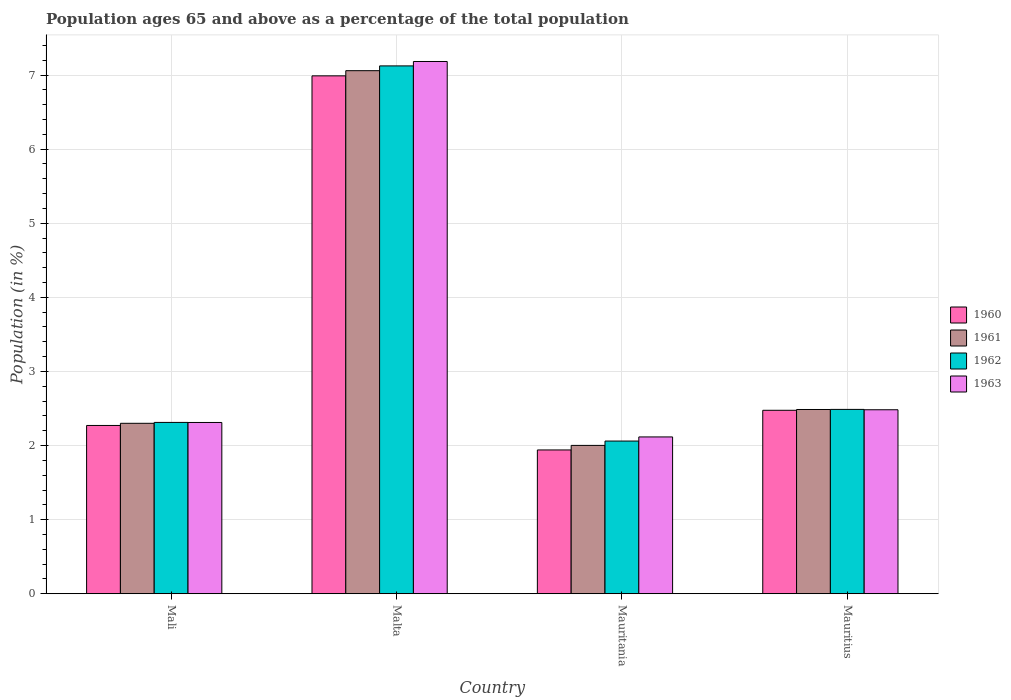How many groups of bars are there?
Provide a succinct answer. 4. How many bars are there on the 1st tick from the right?
Provide a short and direct response. 4. What is the label of the 4th group of bars from the left?
Keep it short and to the point. Mauritius. In how many cases, is the number of bars for a given country not equal to the number of legend labels?
Offer a very short reply. 0. What is the percentage of the population ages 65 and above in 1962 in Mauritania?
Keep it short and to the point. 2.06. Across all countries, what is the maximum percentage of the population ages 65 and above in 1963?
Ensure brevity in your answer.  7.18. Across all countries, what is the minimum percentage of the population ages 65 and above in 1961?
Your answer should be very brief. 2. In which country was the percentage of the population ages 65 and above in 1960 maximum?
Keep it short and to the point. Malta. In which country was the percentage of the population ages 65 and above in 1962 minimum?
Keep it short and to the point. Mauritania. What is the total percentage of the population ages 65 and above in 1963 in the graph?
Your response must be concise. 14.09. What is the difference between the percentage of the population ages 65 and above in 1962 in Mauritania and that in Mauritius?
Offer a terse response. -0.43. What is the difference between the percentage of the population ages 65 and above in 1961 in Mauritius and the percentage of the population ages 65 and above in 1960 in Mali?
Keep it short and to the point. 0.22. What is the average percentage of the population ages 65 and above in 1962 per country?
Make the answer very short. 3.5. What is the difference between the percentage of the population ages 65 and above of/in 1961 and percentage of the population ages 65 and above of/in 1962 in Mauritania?
Offer a terse response. -0.06. In how many countries, is the percentage of the population ages 65 and above in 1960 greater than 6.6?
Your response must be concise. 1. What is the ratio of the percentage of the population ages 65 and above in 1960 in Malta to that in Mauritius?
Your response must be concise. 2.82. What is the difference between the highest and the second highest percentage of the population ages 65 and above in 1960?
Provide a short and direct response. 0.2. What is the difference between the highest and the lowest percentage of the population ages 65 and above in 1961?
Keep it short and to the point. 5.06. In how many countries, is the percentage of the population ages 65 and above in 1960 greater than the average percentage of the population ages 65 and above in 1960 taken over all countries?
Keep it short and to the point. 1. What does the 2nd bar from the left in Malta represents?
Provide a succinct answer. 1961. What does the 3rd bar from the right in Malta represents?
Your answer should be very brief. 1961. Is it the case that in every country, the sum of the percentage of the population ages 65 and above in 1962 and percentage of the population ages 65 and above in 1960 is greater than the percentage of the population ages 65 and above in 1961?
Your answer should be very brief. Yes. How many bars are there?
Keep it short and to the point. 16. How many countries are there in the graph?
Ensure brevity in your answer.  4. Are the values on the major ticks of Y-axis written in scientific E-notation?
Offer a terse response. No. Does the graph contain grids?
Provide a short and direct response. Yes. What is the title of the graph?
Give a very brief answer. Population ages 65 and above as a percentage of the total population. What is the label or title of the Y-axis?
Your answer should be compact. Population (in %). What is the Population (in %) in 1960 in Mali?
Keep it short and to the point. 2.27. What is the Population (in %) of 1961 in Mali?
Your answer should be very brief. 2.3. What is the Population (in %) of 1962 in Mali?
Keep it short and to the point. 2.31. What is the Population (in %) in 1963 in Mali?
Your response must be concise. 2.31. What is the Population (in %) of 1960 in Malta?
Your response must be concise. 6.99. What is the Population (in %) of 1961 in Malta?
Offer a very short reply. 7.06. What is the Population (in %) of 1962 in Malta?
Make the answer very short. 7.12. What is the Population (in %) of 1963 in Malta?
Your answer should be compact. 7.18. What is the Population (in %) in 1960 in Mauritania?
Offer a very short reply. 1.94. What is the Population (in %) of 1961 in Mauritania?
Provide a short and direct response. 2. What is the Population (in %) in 1962 in Mauritania?
Offer a very short reply. 2.06. What is the Population (in %) of 1963 in Mauritania?
Keep it short and to the point. 2.12. What is the Population (in %) in 1960 in Mauritius?
Provide a succinct answer. 2.48. What is the Population (in %) of 1961 in Mauritius?
Your response must be concise. 2.49. What is the Population (in %) of 1962 in Mauritius?
Offer a very short reply. 2.49. What is the Population (in %) in 1963 in Mauritius?
Make the answer very short. 2.48. Across all countries, what is the maximum Population (in %) in 1960?
Your answer should be very brief. 6.99. Across all countries, what is the maximum Population (in %) in 1961?
Your answer should be very brief. 7.06. Across all countries, what is the maximum Population (in %) in 1962?
Offer a very short reply. 7.12. Across all countries, what is the maximum Population (in %) in 1963?
Give a very brief answer. 7.18. Across all countries, what is the minimum Population (in %) of 1960?
Ensure brevity in your answer.  1.94. Across all countries, what is the minimum Population (in %) in 1961?
Your answer should be very brief. 2. Across all countries, what is the minimum Population (in %) in 1962?
Your answer should be compact. 2.06. Across all countries, what is the minimum Population (in %) of 1963?
Your answer should be very brief. 2.12. What is the total Population (in %) of 1960 in the graph?
Keep it short and to the point. 13.68. What is the total Population (in %) of 1961 in the graph?
Give a very brief answer. 13.85. What is the total Population (in %) of 1962 in the graph?
Make the answer very short. 13.98. What is the total Population (in %) of 1963 in the graph?
Make the answer very short. 14.09. What is the difference between the Population (in %) of 1960 in Mali and that in Malta?
Give a very brief answer. -4.72. What is the difference between the Population (in %) in 1961 in Mali and that in Malta?
Your answer should be very brief. -4.76. What is the difference between the Population (in %) of 1962 in Mali and that in Malta?
Make the answer very short. -4.81. What is the difference between the Population (in %) of 1963 in Mali and that in Malta?
Your response must be concise. -4.87. What is the difference between the Population (in %) of 1960 in Mali and that in Mauritania?
Give a very brief answer. 0.33. What is the difference between the Population (in %) in 1961 in Mali and that in Mauritania?
Give a very brief answer. 0.3. What is the difference between the Population (in %) of 1962 in Mali and that in Mauritania?
Provide a succinct answer. 0.25. What is the difference between the Population (in %) in 1963 in Mali and that in Mauritania?
Provide a succinct answer. 0.2. What is the difference between the Population (in %) in 1960 in Mali and that in Mauritius?
Your answer should be compact. -0.2. What is the difference between the Population (in %) in 1961 in Mali and that in Mauritius?
Give a very brief answer. -0.19. What is the difference between the Population (in %) in 1962 in Mali and that in Mauritius?
Give a very brief answer. -0.18. What is the difference between the Population (in %) of 1963 in Mali and that in Mauritius?
Ensure brevity in your answer.  -0.17. What is the difference between the Population (in %) in 1960 in Malta and that in Mauritania?
Keep it short and to the point. 5.05. What is the difference between the Population (in %) of 1961 in Malta and that in Mauritania?
Provide a succinct answer. 5.06. What is the difference between the Population (in %) of 1962 in Malta and that in Mauritania?
Provide a succinct answer. 5.06. What is the difference between the Population (in %) in 1963 in Malta and that in Mauritania?
Offer a terse response. 5.07. What is the difference between the Population (in %) in 1960 in Malta and that in Mauritius?
Your response must be concise. 4.51. What is the difference between the Population (in %) in 1961 in Malta and that in Mauritius?
Keep it short and to the point. 4.57. What is the difference between the Population (in %) of 1962 in Malta and that in Mauritius?
Offer a very short reply. 4.64. What is the difference between the Population (in %) in 1963 in Malta and that in Mauritius?
Offer a terse response. 4.7. What is the difference between the Population (in %) of 1960 in Mauritania and that in Mauritius?
Keep it short and to the point. -0.54. What is the difference between the Population (in %) in 1961 in Mauritania and that in Mauritius?
Keep it short and to the point. -0.48. What is the difference between the Population (in %) of 1962 in Mauritania and that in Mauritius?
Provide a short and direct response. -0.43. What is the difference between the Population (in %) of 1963 in Mauritania and that in Mauritius?
Provide a short and direct response. -0.37. What is the difference between the Population (in %) in 1960 in Mali and the Population (in %) in 1961 in Malta?
Give a very brief answer. -4.79. What is the difference between the Population (in %) in 1960 in Mali and the Population (in %) in 1962 in Malta?
Your answer should be very brief. -4.85. What is the difference between the Population (in %) of 1960 in Mali and the Population (in %) of 1963 in Malta?
Your answer should be very brief. -4.91. What is the difference between the Population (in %) in 1961 in Mali and the Population (in %) in 1962 in Malta?
Your answer should be compact. -4.82. What is the difference between the Population (in %) of 1961 in Mali and the Population (in %) of 1963 in Malta?
Provide a short and direct response. -4.88. What is the difference between the Population (in %) of 1962 in Mali and the Population (in %) of 1963 in Malta?
Provide a short and direct response. -4.87. What is the difference between the Population (in %) in 1960 in Mali and the Population (in %) in 1961 in Mauritania?
Provide a short and direct response. 0.27. What is the difference between the Population (in %) in 1960 in Mali and the Population (in %) in 1962 in Mauritania?
Offer a very short reply. 0.21. What is the difference between the Population (in %) of 1960 in Mali and the Population (in %) of 1963 in Mauritania?
Keep it short and to the point. 0.15. What is the difference between the Population (in %) in 1961 in Mali and the Population (in %) in 1962 in Mauritania?
Your response must be concise. 0.24. What is the difference between the Population (in %) in 1961 in Mali and the Population (in %) in 1963 in Mauritania?
Make the answer very short. 0.18. What is the difference between the Population (in %) of 1962 in Mali and the Population (in %) of 1963 in Mauritania?
Offer a very short reply. 0.2. What is the difference between the Population (in %) of 1960 in Mali and the Population (in %) of 1961 in Mauritius?
Offer a very short reply. -0.22. What is the difference between the Population (in %) in 1960 in Mali and the Population (in %) in 1962 in Mauritius?
Give a very brief answer. -0.22. What is the difference between the Population (in %) in 1960 in Mali and the Population (in %) in 1963 in Mauritius?
Offer a very short reply. -0.21. What is the difference between the Population (in %) in 1961 in Mali and the Population (in %) in 1962 in Mauritius?
Provide a succinct answer. -0.19. What is the difference between the Population (in %) of 1961 in Mali and the Population (in %) of 1963 in Mauritius?
Your response must be concise. -0.18. What is the difference between the Population (in %) in 1962 in Mali and the Population (in %) in 1963 in Mauritius?
Offer a very short reply. -0.17. What is the difference between the Population (in %) in 1960 in Malta and the Population (in %) in 1961 in Mauritania?
Provide a succinct answer. 4.99. What is the difference between the Population (in %) in 1960 in Malta and the Population (in %) in 1962 in Mauritania?
Keep it short and to the point. 4.93. What is the difference between the Population (in %) of 1960 in Malta and the Population (in %) of 1963 in Mauritania?
Provide a short and direct response. 4.87. What is the difference between the Population (in %) in 1961 in Malta and the Population (in %) in 1962 in Mauritania?
Offer a terse response. 5. What is the difference between the Population (in %) of 1961 in Malta and the Population (in %) of 1963 in Mauritania?
Offer a very short reply. 4.94. What is the difference between the Population (in %) in 1962 in Malta and the Population (in %) in 1963 in Mauritania?
Your answer should be compact. 5.01. What is the difference between the Population (in %) in 1960 in Malta and the Population (in %) in 1961 in Mauritius?
Your answer should be very brief. 4.5. What is the difference between the Population (in %) of 1960 in Malta and the Population (in %) of 1962 in Mauritius?
Your answer should be compact. 4.5. What is the difference between the Population (in %) of 1960 in Malta and the Population (in %) of 1963 in Mauritius?
Your response must be concise. 4.51. What is the difference between the Population (in %) of 1961 in Malta and the Population (in %) of 1962 in Mauritius?
Your answer should be very brief. 4.57. What is the difference between the Population (in %) in 1961 in Malta and the Population (in %) in 1963 in Mauritius?
Make the answer very short. 4.58. What is the difference between the Population (in %) of 1962 in Malta and the Population (in %) of 1963 in Mauritius?
Provide a succinct answer. 4.64. What is the difference between the Population (in %) of 1960 in Mauritania and the Population (in %) of 1961 in Mauritius?
Ensure brevity in your answer.  -0.55. What is the difference between the Population (in %) in 1960 in Mauritania and the Population (in %) in 1962 in Mauritius?
Provide a short and direct response. -0.55. What is the difference between the Population (in %) in 1960 in Mauritania and the Population (in %) in 1963 in Mauritius?
Provide a succinct answer. -0.54. What is the difference between the Population (in %) of 1961 in Mauritania and the Population (in %) of 1962 in Mauritius?
Keep it short and to the point. -0.49. What is the difference between the Population (in %) in 1961 in Mauritania and the Population (in %) in 1963 in Mauritius?
Provide a succinct answer. -0.48. What is the difference between the Population (in %) of 1962 in Mauritania and the Population (in %) of 1963 in Mauritius?
Give a very brief answer. -0.42. What is the average Population (in %) in 1960 per country?
Ensure brevity in your answer.  3.42. What is the average Population (in %) in 1961 per country?
Ensure brevity in your answer.  3.46. What is the average Population (in %) in 1962 per country?
Ensure brevity in your answer.  3.5. What is the average Population (in %) of 1963 per country?
Offer a very short reply. 3.52. What is the difference between the Population (in %) in 1960 and Population (in %) in 1961 in Mali?
Offer a terse response. -0.03. What is the difference between the Population (in %) of 1960 and Population (in %) of 1962 in Mali?
Offer a very short reply. -0.04. What is the difference between the Population (in %) of 1960 and Population (in %) of 1963 in Mali?
Keep it short and to the point. -0.04. What is the difference between the Population (in %) of 1961 and Population (in %) of 1962 in Mali?
Your answer should be compact. -0.01. What is the difference between the Population (in %) of 1961 and Population (in %) of 1963 in Mali?
Give a very brief answer. -0.01. What is the difference between the Population (in %) of 1962 and Population (in %) of 1963 in Mali?
Your answer should be very brief. 0. What is the difference between the Population (in %) in 1960 and Population (in %) in 1961 in Malta?
Keep it short and to the point. -0.07. What is the difference between the Population (in %) of 1960 and Population (in %) of 1962 in Malta?
Offer a very short reply. -0.13. What is the difference between the Population (in %) in 1960 and Population (in %) in 1963 in Malta?
Provide a succinct answer. -0.19. What is the difference between the Population (in %) in 1961 and Population (in %) in 1962 in Malta?
Provide a succinct answer. -0.06. What is the difference between the Population (in %) in 1961 and Population (in %) in 1963 in Malta?
Give a very brief answer. -0.12. What is the difference between the Population (in %) of 1962 and Population (in %) of 1963 in Malta?
Keep it short and to the point. -0.06. What is the difference between the Population (in %) in 1960 and Population (in %) in 1961 in Mauritania?
Offer a terse response. -0.06. What is the difference between the Population (in %) of 1960 and Population (in %) of 1962 in Mauritania?
Your response must be concise. -0.12. What is the difference between the Population (in %) in 1960 and Population (in %) in 1963 in Mauritania?
Offer a terse response. -0.18. What is the difference between the Population (in %) of 1961 and Population (in %) of 1962 in Mauritania?
Your answer should be very brief. -0.06. What is the difference between the Population (in %) of 1961 and Population (in %) of 1963 in Mauritania?
Your answer should be compact. -0.11. What is the difference between the Population (in %) in 1962 and Population (in %) in 1963 in Mauritania?
Ensure brevity in your answer.  -0.06. What is the difference between the Population (in %) of 1960 and Population (in %) of 1961 in Mauritius?
Your response must be concise. -0.01. What is the difference between the Population (in %) in 1960 and Population (in %) in 1962 in Mauritius?
Give a very brief answer. -0.01. What is the difference between the Population (in %) of 1960 and Population (in %) of 1963 in Mauritius?
Keep it short and to the point. -0.01. What is the difference between the Population (in %) of 1961 and Population (in %) of 1962 in Mauritius?
Make the answer very short. -0. What is the difference between the Population (in %) of 1961 and Population (in %) of 1963 in Mauritius?
Ensure brevity in your answer.  0. What is the difference between the Population (in %) in 1962 and Population (in %) in 1963 in Mauritius?
Keep it short and to the point. 0. What is the ratio of the Population (in %) in 1960 in Mali to that in Malta?
Your answer should be compact. 0.32. What is the ratio of the Population (in %) in 1961 in Mali to that in Malta?
Give a very brief answer. 0.33. What is the ratio of the Population (in %) in 1962 in Mali to that in Malta?
Your answer should be very brief. 0.32. What is the ratio of the Population (in %) in 1963 in Mali to that in Malta?
Provide a succinct answer. 0.32. What is the ratio of the Population (in %) in 1960 in Mali to that in Mauritania?
Provide a short and direct response. 1.17. What is the ratio of the Population (in %) of 1961 in Mali to that in Mauritania?
Provide a short and direct response. 1.15. What is the ratio of the Population (in %) of 1962 in Mali to that in Mauritania?
Provide a short and direct response. 1.12. What is the ratio of the Population (in %) of 1963 in Mali to that in Mauritania?
Your answer should be compact. 1.09. What is the ratio of the Population (in %) of 1960 in Mali to that in Mauritius?
Offer a terse response. 0.92. What is the ratio of the Population (in %) in 1961 in Mali to that in Mauritius?
Your answer should be very brief. 0.93. What is the ratio of the Population (in %) in 1962 in Mali to that in Mauritius?
Provide a short and direct response. 0.93. What is the ratio of the Population (in %) of 1963 in Mali to that in Mauritius?
Your response must be concise. 0.93. What is the ratio of the Population (in %) in 1960 in Malta to that in Mauritania?
Give a very brief answer. 3.6. What is the ratio of the Population (in %) of 1961 in Malta to that in Mauritania?
Give a very brief answer. 3.53. What is the ratio of the Population (in %) of 1962 in Malta to that in Mauritania?
Keep it short and to the point. 3.46. What is the ratio of the Population (in %) of 1963 in Malta to that in Mauritania?
Your answer should be compact. 3.39. What is the ratio of the Population (in %) of 1960 in Malta to that in Mauritius?
Make the answer very short. 2.82. What is the ratio of the Population (in %) of 1961 in Malta to that in Mauritius?
Provide a short and direct response. 2.84. What is the ratio of the Population (in %) in 1962 in Malta to that in Mauritius?
Make the answer very short. 2.86. What is the ratio of the Population (in %) in 1963 in Malta to that in Mauritius?
Your response must be concise. 2.89. What is the ratio of the Population (in %) in 1960 in Mauritania to that in Mauritius?
Give a very brief answer. 0.78. What is the ratio of the Population (in %) of 1961 in Mauritania to that in Mauritius?
Offer a very short reply. 0.81. What is the ratio of the Population (in %) of 1962 in Mauritania to that in Mauritius?
Offer a very short reply. 0.83. What is the ratio of the Population (in %) in 1963 in Mauritania to that in Mauritius?
Provide a short and direct response. 0.85. What is the difference between the highest and the second highest Population (in %) of 1960?
Your answer should be very brief. 4.51. What is the difference between the highest and the second highest Population (in %) in 1961?
Make the answer very short. 4.57. What is the difference between the highest and the second highest Population (in %) in 1962?
Make the answer very short. 4.64. What is the difference between the highest and the second highest Population (in %) in 1963?
Provide a short and direct response. 4.7. What is the difference between the highest and the lowest Population (in %) in 1960?
Provide a short and direct response. 5.05. What is the difference between the highest and the lowest Population (in %) in 1961?
Your response must be concise. 5.06. What is the difference between the highest and the lowest Population (in %) of 1962?
Your answer should be compact. 5.06. What is the difference between the highest and the lowest Population (in %) in 1963?
Your response must be concise. 5.07. 